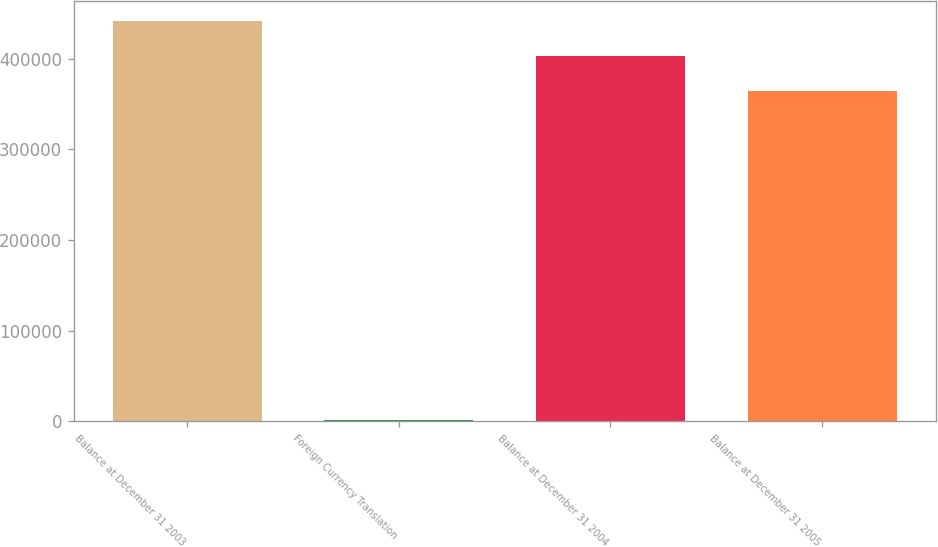Convert chart to OTSL. <chart><loc_0><loc_0><loc_500><loc_500><bar_chart><fcel>Balance at December 31 2003<fcel>Foreign Currency Translation<fcel>Balance at December 31 2004<fcel>Balance at December 31 2005<nl><fcel>441099<fcel>1887<fcel>402755<fcel>364411<nl></chart> 